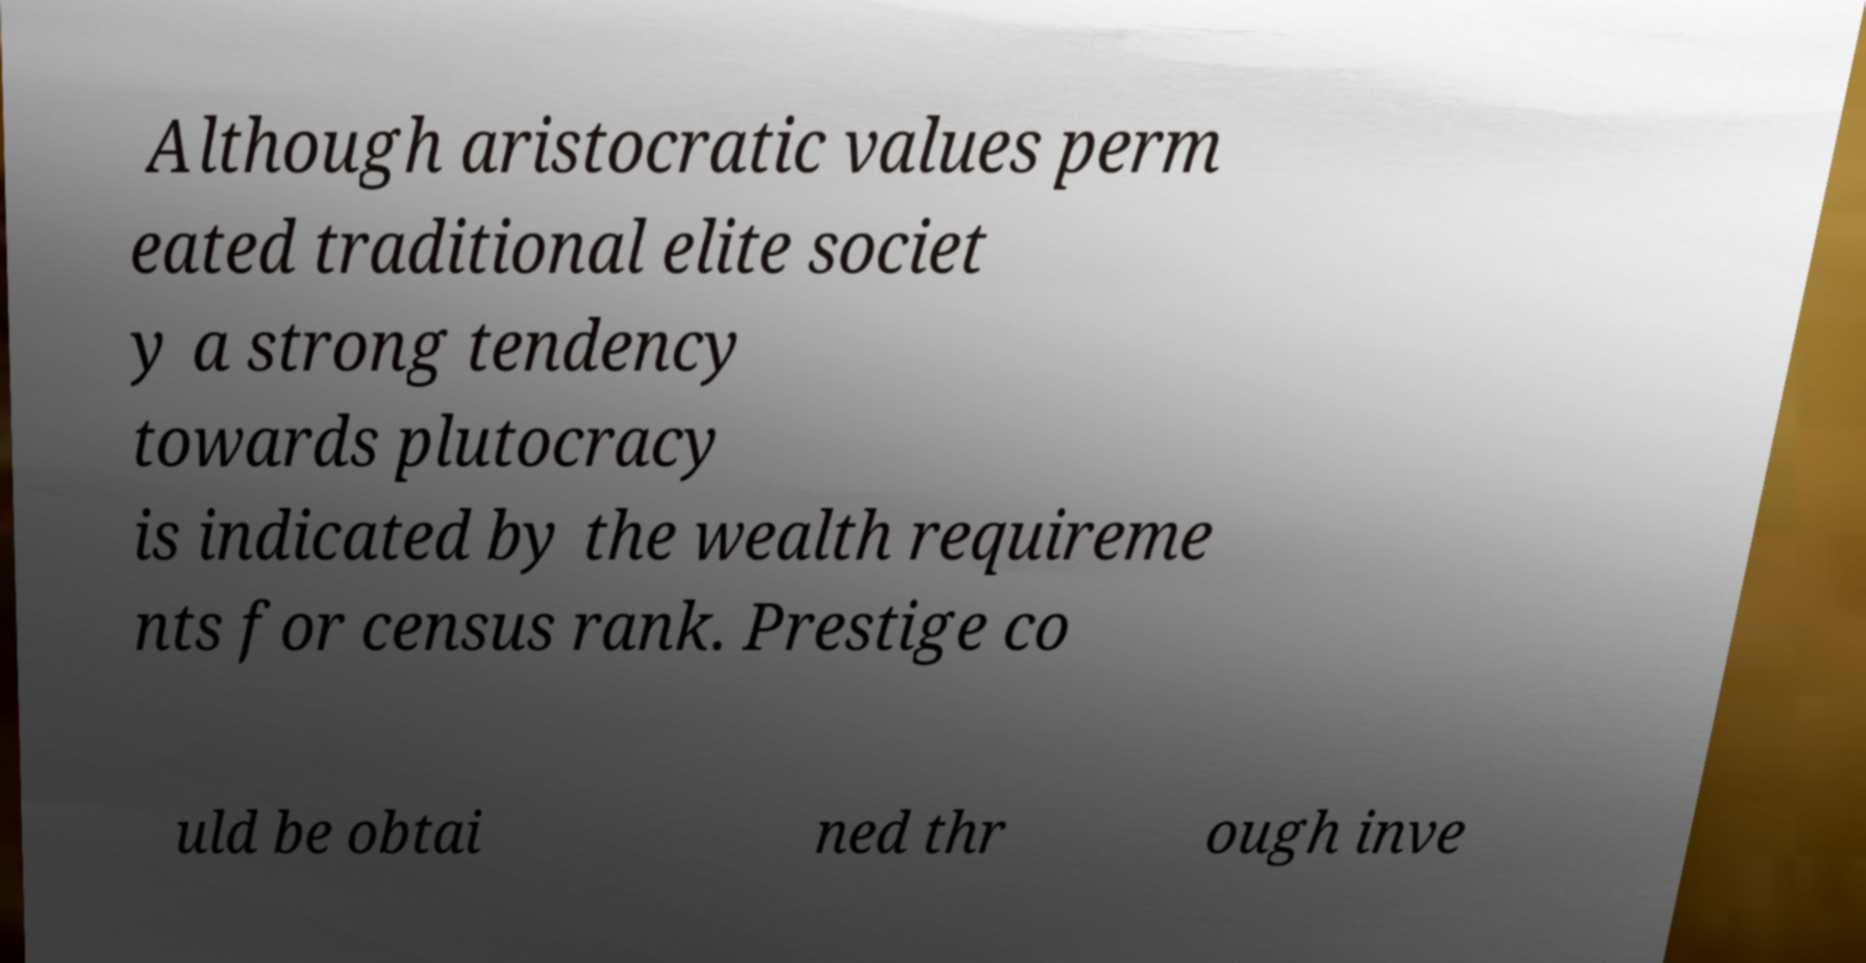Can you accurately transcribe the text from the provided image for me? Although aristocratic values perm eated traditional elite societ y a strong tendency towards plutocracy is indicated by the wealth requireme nts for census rank. Prestige co uld be obtai ned thr ough inve 